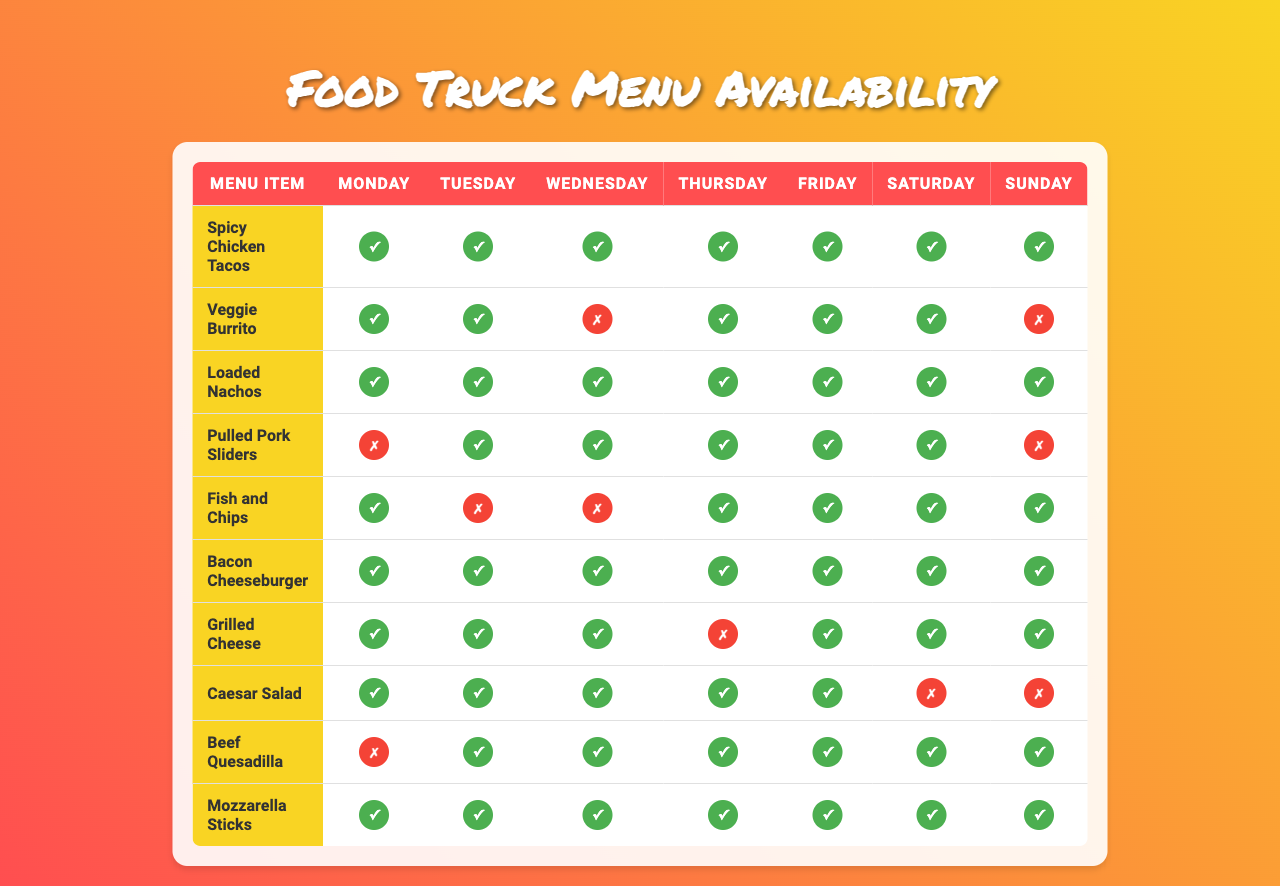What menu items are available on Saturday? By looking at the table, you can see the items listed and check their availability for Saturday. Spicy Chicken Tacos, Veggie Burrito, Loaded Nachos, Pulled Pork Sliders, Bacon Cheeseburger, Grilled Cheese, Beef Quesadilla, and Mozzarella Sticks are all available.
Answer: Spicy Chicken Tacos, Veggie Burrito, Loaded Nachos, Pulled Pork Sliders, Bacon Cheeseburger, Grilled Cheese, Beef Quesadilla, Mozzarella Sticks Is the Caesar Salad available on Wednesday? To check the availability of Caesar Salad on Wednesday, I look at the row for the Caesar Salad and see the icon for Wednesday. It is an '✗' symbol, indicating that it is unavailable.
Answer: No How many items are available on Sunday? Count the available items (the ones marked with a '✓') for each menu item on Sunday. By tallying, I find that 6 items are available that day.
Answer: 6 Which item is unavailable on Fridays? I review each menu item for availability on Friday by locating the appropriate column in the table. Fish and Chips is the item that is marked as unavailable (✗).
Answer: Fish and Chips What's the average number of available items across all days? Count the total available items for each day, then sum those counts and divide by the number of days (7). The totals are: 9, 8, 7, 8, 7, 10, 8, which adds up to 57. Dividing by 7 gives an average of 8.14, rounded down to 8.
Answer: 8 Are there any food items that are unavailable both on Saturday and Sunday? I check both the Saturday and Sunday columns for each menu item, confirming that Pulled Pork Sliders and Veggie Burrito are both marked as unavailable (✗) on those days.
Answer: Yes Which menu item has the most availability throughout the week? I examine all items for their total availability by counting '✓' for each item across all days. The Loaded Nachos item shows a total of 7 available days, and this is the highest among all items.
Answer: Loaded Nachos Are there any days when both Fish and Chips and Grilled Cheese are unavailable? By reviewing the rows of both items for each day, I see that Fish and Chips is unavailable on Tuesday and Grilled Cheese is unavailable on Thursday, but there are no days where both are marked as unavailable at the same time.
Answer: No 